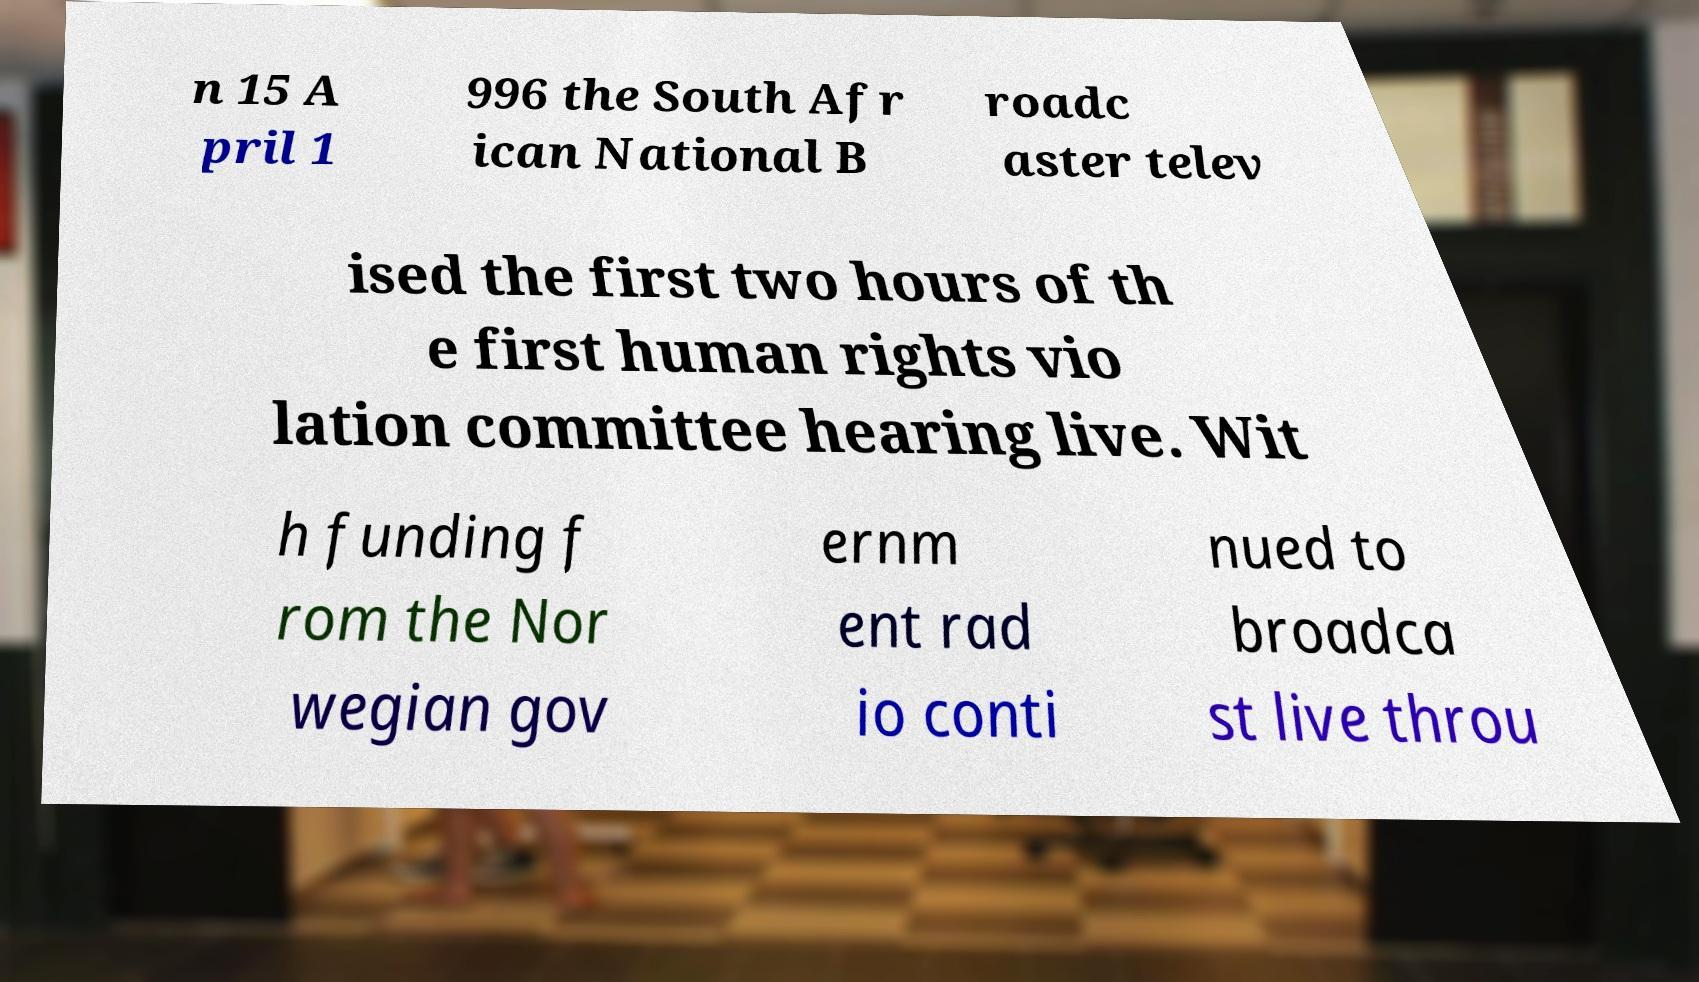Please identify and transcribe the text found in this image. n 15 A pril 1 996 the South Afr ican National B roadc aster telev ised the first two hours of th e first human rights vio lation committee hearing live. Wit h funding f rom the Nor wegian gov ernm ent rad io conti nued to broadca st live throu 